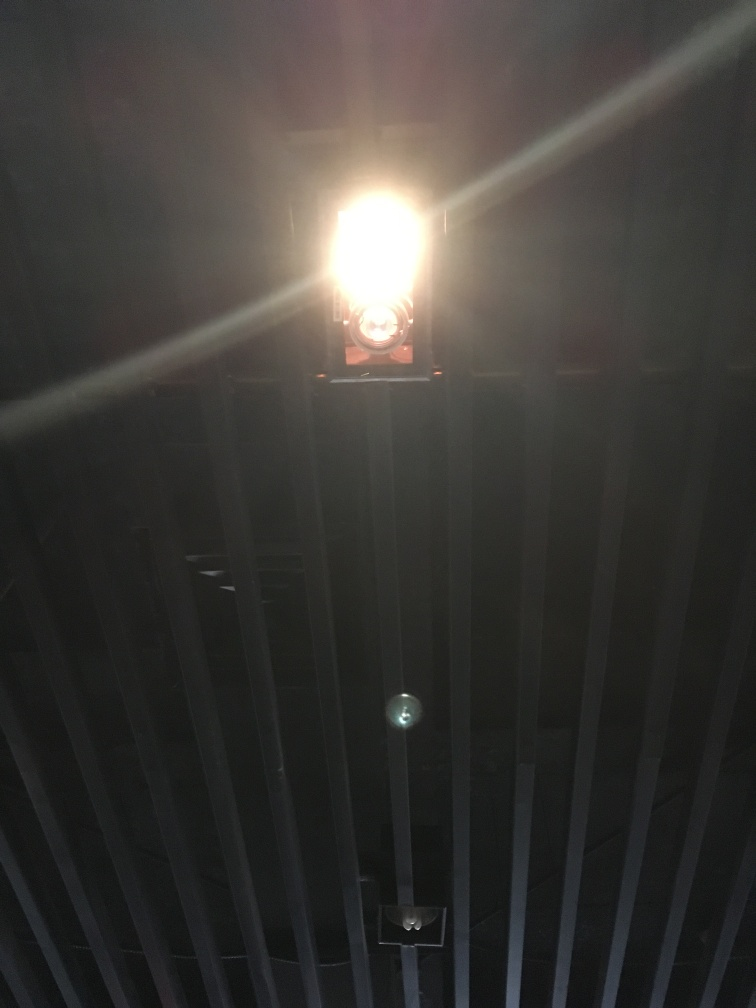What mood does this image evoke, and what elements of the image contribute to that mood? The image evokes a mood of mystery and possibly suspense. The strong backlight that washes out details and the bars in the foreground contribute to a sense of confinement or isolation. These elements could imply a narrative or emotion that resonates with themes of separation, secrecy, or introspection. 